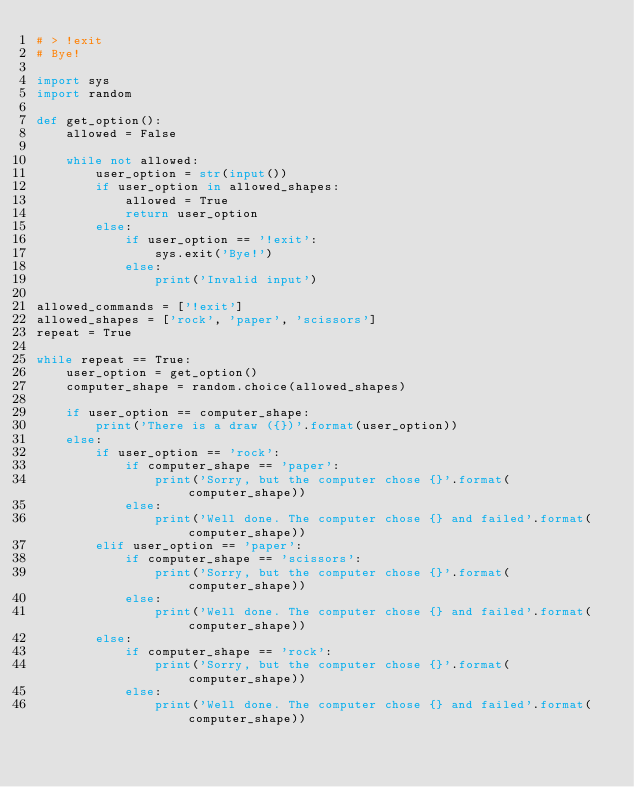Convert code to text. <code><loc_0><loc_0><loc_500><loc_500><_Python_># > !exit
# Bye!

import sys
import random

def get_option():
    allowed = False

    while not allowed:
        user_option = str(input())
        if user_option in allowed_shapes:
            allowed = True
            return user_option
        else:
            if user_option == '!exit':
                sys.exit('Bye!')
            else:
                print('Invalid input')

allowed_commands = ['!exit']
allowed_shapes = ['rock', 'paper', 'scissors']
repeat = True

while repeat == True:
    user_option = get_option()
    computer_shape = random.choice(allowed_shapes)
    
    if user_option == computer_shape:
        print('There is a draw ({})'.format(user_option))
    else:
        if user_option == 'rock':
            if computer_shape == 'paper':
                print('Sorry, but the computer chose {}'.format(computer_shape))
            else:
                print('Well done. The computer chose {} and failed'.format(computer_shape))
        elif user_option == 'paper':
            if computer_shape == 'scissors':
                print('Sorry, but the computer chose {}'.format(computer_shape))
            else:
                print('Well done. The computer chose {} and failed'.format(computer_shape))
        else:
            if computer_shape == 'rock':
                print('Sorry, but the computer chose {}'.format(computer_shape))
            else:
                print('Well done. The computer chose {} and failed'.format(computer_shape))</code> 